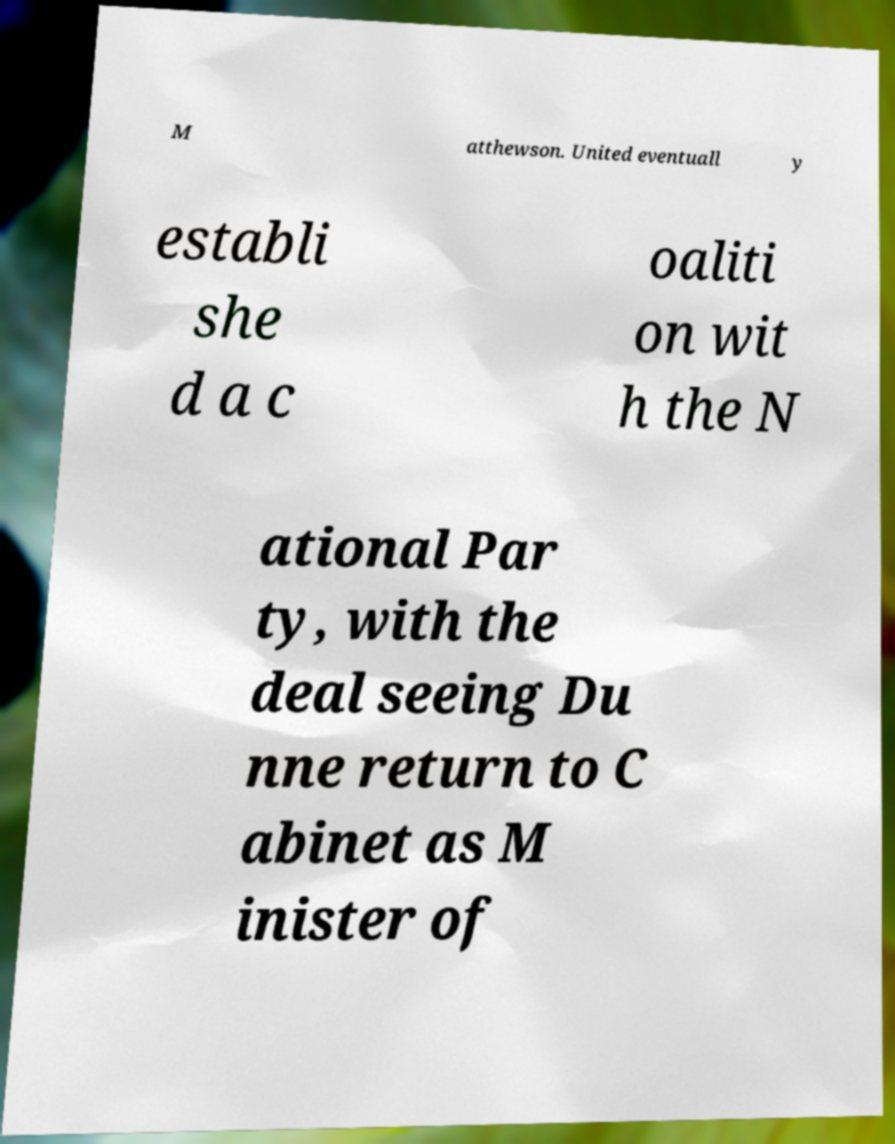Please read and relay the text visible in this image. What does it say? M atthewson. United eventuall y establi she d a c oaliti on wit h the N ational Par ty, with the deal seeing Du nne return to C abinet as M inister of 